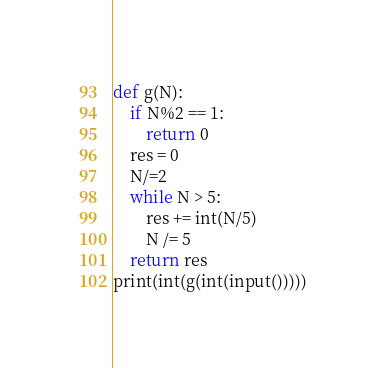<code> <loc_0><loc_0><loc_500><loc_500><_Python_>def g(N):
    if N%2 == 1:
        return 0
    res = 0
    N/=2
    while N > 5:
        res += int(N/5)
        N /= 5
    return res
print(int(g(int(input()))))</code> 